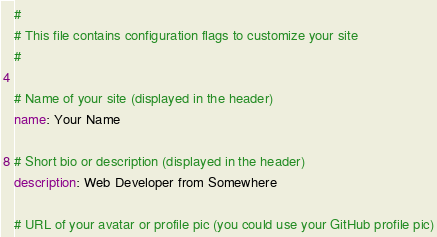Convert code to text. <code><loc_0><loc_0><loc_500><loc_500><_YAML_>#
# This file contains configuration flags to customize your site
#

# Name of your site (displayed in the header)
name: Your Name

# Short bio or description (displayed in the header)
description: Web Developer from Somewhere

# URL of your avatar or profile pic (you could use your GitHub profile pic)</code> 